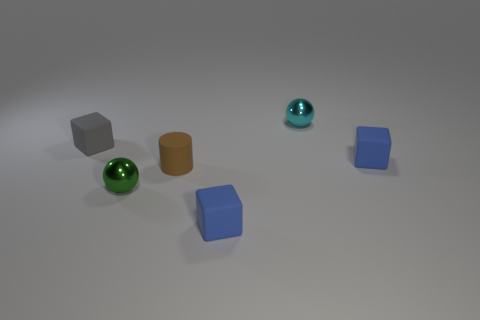Subtract all blue cubes. How many cubes are left? 1 Add 4 large yellow shiny blocks. How many objects exist? 10 Subtract all gray cubes. How many cubes are left? 2 Subtract all brown spheres. How many blue cubes are left? 2 Subtract all cylinders. How many objects are left? 5 Add 5 tiny brown objects. How many tiny brown objects are left? 6 Add 3 large matte blocks. How many large matte blocks exist? 3 Subtract 0 gray cylinders. How many objects are left? 6 Subtract 1 cylinders. How many cylinders are left? 0 Subtract all cyan blocks. Subtract all gray spheres. How many blocks are left? 3 